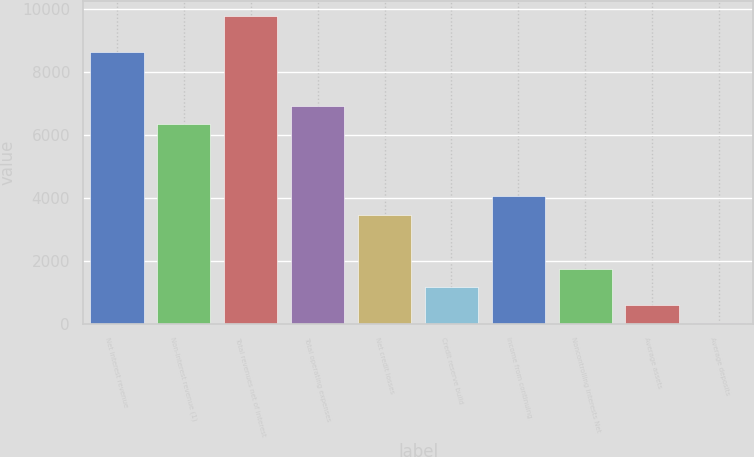Convert chart. <chart><loc_0><loc_0><loc_500><loc_500><bar_chart><fcel>Net interest revenue<fcel>Non-interest revenue (1)<fcel>Total revenues net of interest<fcel>Total operating expenses<fcel>Net credit losses<fcel>Credit reserve build<fcel>Income from continuing<fcel>Noncontrolling interests Net<fcel>Average assets<fcel>Average deposits<nl><fcel>8625.65<fcel>6333.13<fcel>9771.91<fcel>6906.26<fcel>3467.48<fcel>1174.96<fcel>4040.61<fcel>1748.09<fcel>601.83<fcel>28.7<nl></chart> 